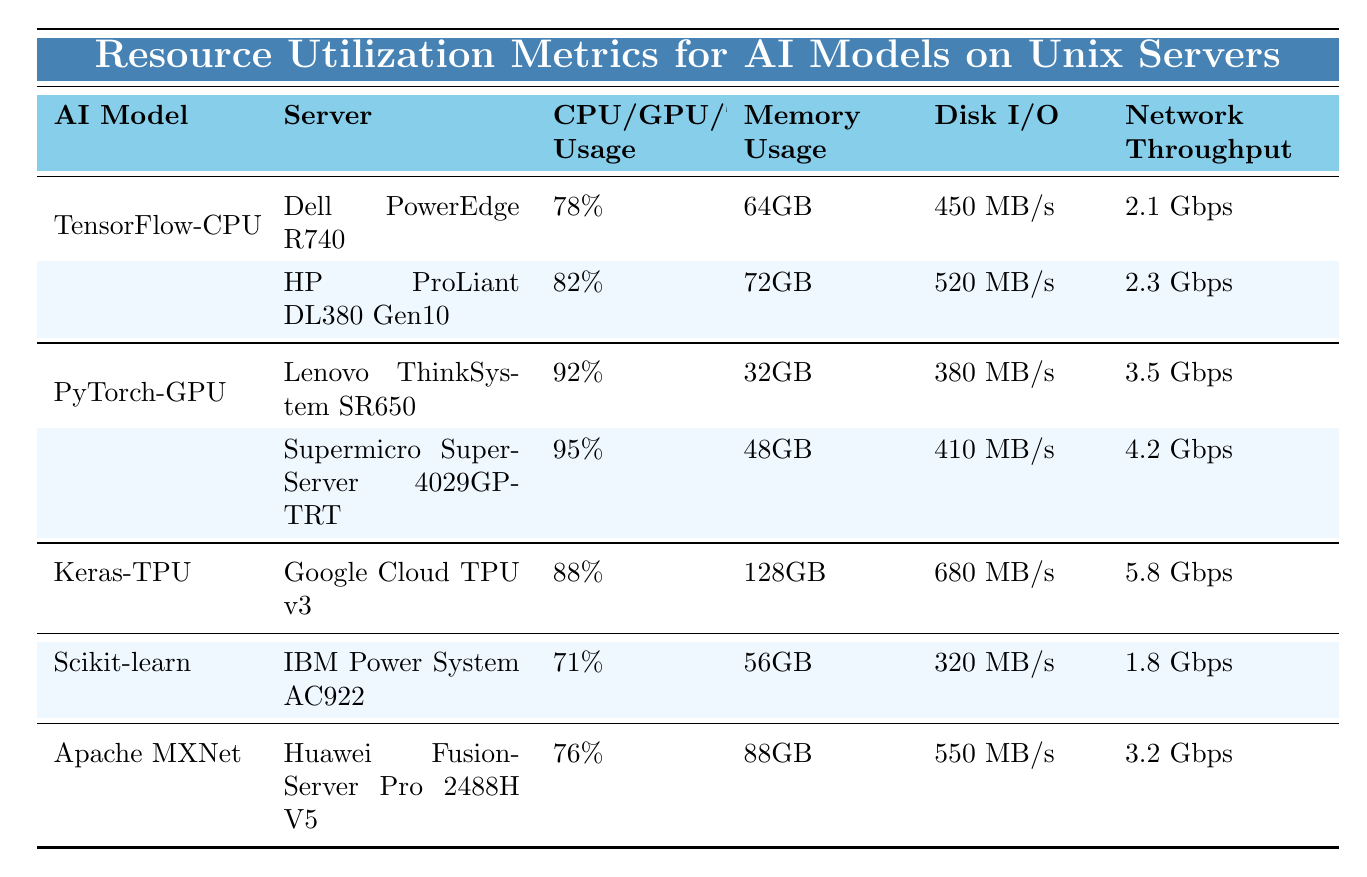What is the highest CPU usage recorded among the AI models? The table shows CPU usage metrics for TensorFlow-CPU, Scikit-learn, and Apache MXNet. The maximum CPU usage is 82%, recorded by the HP ProLiant DL380 Gen10 server under TensorFlow-CPU.
Answer: 82% Which server has the highest memory usage? The table lists memory usage for all servers. The Google Cloud TPU v3 for the Keras-TPU model has the highest memory usage of 128GB.
Answer: 128GB What percentage of GPU usage was recorded for the Supermicro SuperServer 4029GP-TRT? The data for the Supermicro SuperServer 4029GP-TRT shows a GPU usage of 95% under the PyTorch-GPU model.
Answer: 95% Is the network throughput for the Dell PowerEdge R740 higher than that of the IBM Power System AC922? The Dell PowerEdge R740 has a network throughput of 2.1 Gbps, while the IBM Power System AC922 has 1.8 Gbps. Thus, the former's throughput is higher.
Answer: Yes What is the total disk I/O for both servers running TensorFlow-CPU? The disk I/O values for the Dell PowerEdge R740 (450 MB/s) and HP ProLiant DL380 Gen10 (520 MB/s) need to be summed. 450 + 520 = 970 MB/s. Therefore, the total is 970 MB/s.
Answer: 970 MB/s What is the average memory usage across all AI models listed in the table? The memory usage values are 64GB, 72GB, 128GB, 56GB, and 88GB for each model. Summing these gives 64 + 72 + 128 + 56 + 88 = 408GB. Dividing by the number of models (5) gives an average of 408/5 = 81.6GB.
Answer: 81.6GB Are the disk I/O values for the PyTorch-GPU model generally higher than for the TensorFlow-CPU model? The disk I/O values are 380 MB/s and 410 MB/s for the two servers running PyTorch and GPT respectively. While one server has lower disk I/O, the other has higher, indicating mixed results, but generally, Pytorch is lower.
Answer: No Which AI model has the best network throughput, and what is that value? The Keras-TPU on the Google Cloud TPU v3 shows a network throughput of 5.8 Gbps, which is the highest among all models.
Answer: Keras-TPU, 5.8 Gbps What is the difference in CPU usage between the highest and lowest recorded for TensorFlow-CPU? The two CPU usage values under TensorFlow-CPU are 78% and 82%. The difference is calculated by subtracting the lower from the higher: 82% - 78% = 4%.
Answer: 4% 